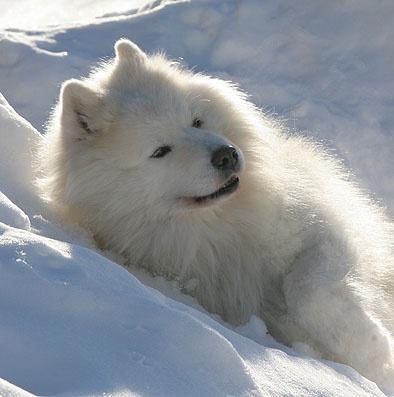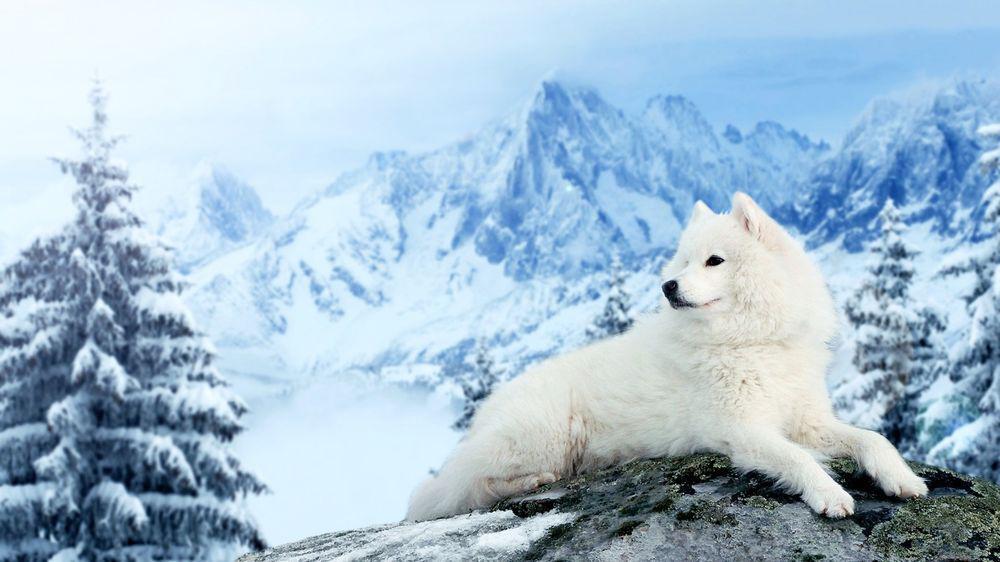The first image is the image on the left, the second image is the image on the right. Assess this claim about the two images: "Exactly two large white dogs are shown in snowy outdoor areas with trees in the background, one of them wearing a harness.". Correct or not? Answer yes or no. No. The first image is the image on the left, the second image is the image on the right. Given the left and right images, does the statement "An image shows a white dog wearing a harness in a wintry scene." hold true? Answer yes or no. No. 